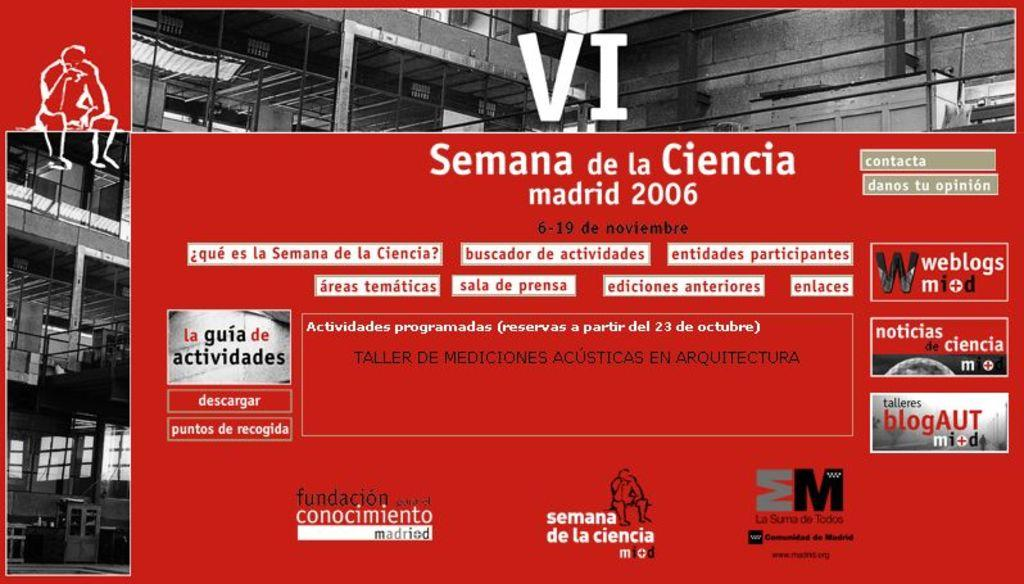<image>
Share a concise interpretation of the image provided. A black and red poster for Semana de la Ciencia madrid 2006. 